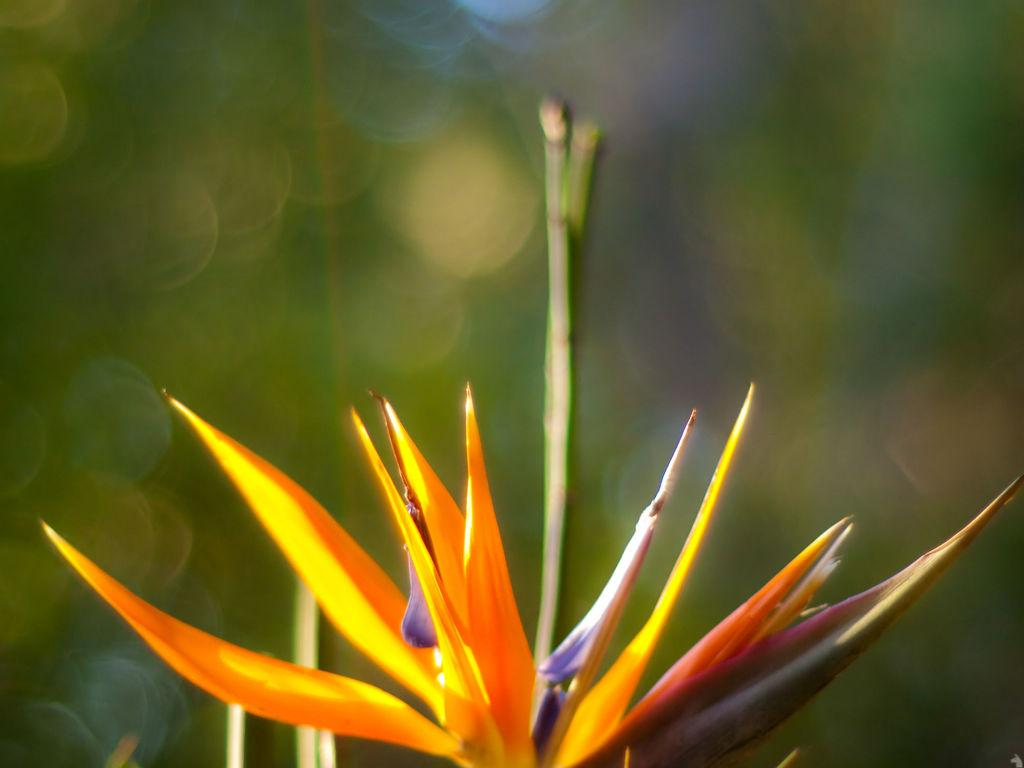What is the main subject of the image? There is a colorful flower in the image. Can you describe the background of the image? The background of the image has blue and green colors. How many cherries are hanging from the flower in the image? There are no cherries present in the image; it features a colorful flower. What type of insurance policy is mentioned in the image? There is no mention of insurance in the image; it features a colorful flower and a background with blue and green colors. 